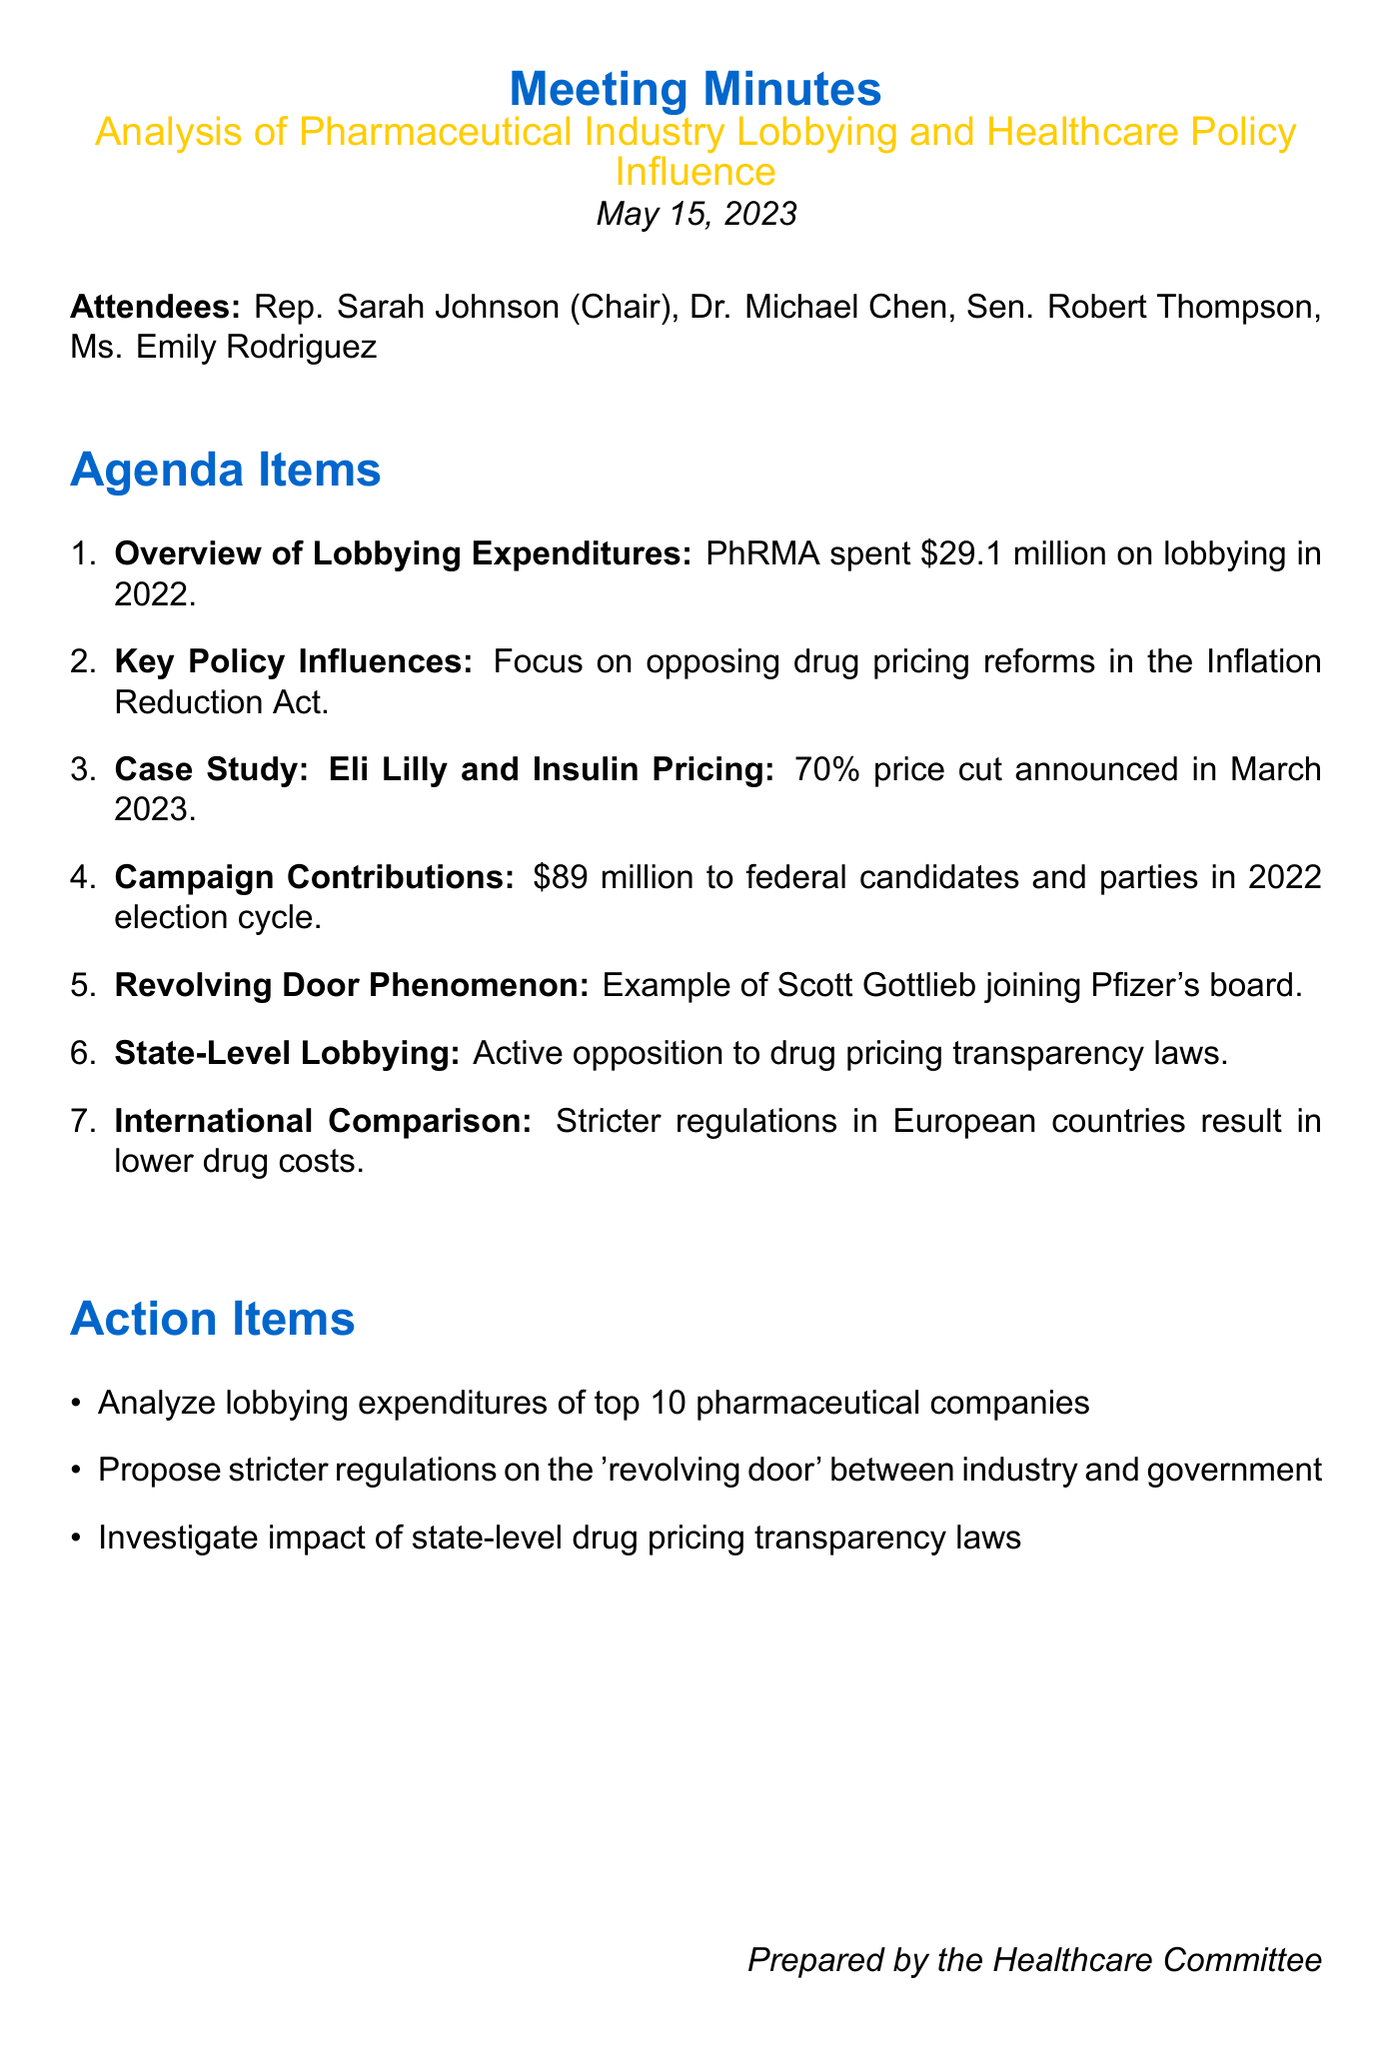What was the lobbying expenditure of PhRMA in 2022? The meeting notes state that PhRMA spent $29.1 million on lobbying efforts in 2022.
Answer: $29.1 million What was the focus of recent lobbying efforts mentioned in the document? The document indicates that recent lobbying efforts have focused on opposing drug pricing reforms in the Inflation Reduction Act.
Answer: Opposing drug pricing reforms Who announced a significant price cut on insulin products in March 2023? The document contains a case study highlighting that Eli Lilly announced a 70% price cut for its insulin products.
Answer: Eli Lilly How much did the pharmaceutical and health products industry contribute in the 2022 election cycle? The minutes record that the industry contributed $89 million to federal candidates and parties during the 2022 election cycle.
Answer: $89 million What notable phenomenon is raised in the document regarding industry and government? The minutes refer to the "Revolving Door Phenomenon," highlighting transitions between industry and government roles.
Answer: Revolving Door Phenomenon What does the document suggest about pharmaceutical lobbying regulations in European countries? It compares the U.S. to European countries, stating that many have stricter regulations on pharmaceutical lobbying and pricing.
Answer: Stricter regulations What action item involves analyzing pharmaceutical company expenditures? The action item specifies conducting a detailed analysis of lobbying expenditures by the top 10 pharmaceutical companies.
Answer: Analyze lobbying expenditures What is a key concern related to former FDA Commissioner Scott Gottlieb? The minutes mention concerns about regulatory capture related to Scott Gottlieb joining the board of Pfizer shortly after leaving his position.
Answer: Regulatory capture How has the industry responded to state-level drug pricing transparency laws? The document notes that the industry has actively lobbied against state-level drug pricing transparency laws.
Answer: Actively lobbied against transparency laws 